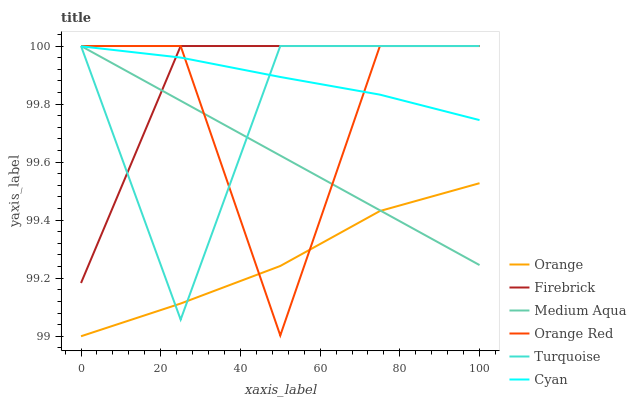Does Orange have the minimum area under the curve?
Answer yes or no. Yes. Does Firebrick have the maximum area under the curve?
Answer yes or no. Yes. Does Medium Aqua have the minimum area under the curve?
Answer yes or no. No. Does Medium Aqua have the maximum area under the curve?
Answer yes or no. No. Is Medium Aqua the smoothest?
Answer yes or no. Yes. Is Orange Red the roughest?
Answer yes or no. Yes. Is Firebrick the smoothest?
Answer yes or no. No. Is Firebrick the roughest?
Answer yes or no. No. Does Orange have the lowest value?
Answer yes or no. Yes. Does Firebrick have the lowest value?
Answer yes or no. No. Does Orange Red have the highest value?
Answer yes or no. Yes. Does Orange have the highest value?
Answer yes or no. No. Is Orange less than Cyan?
Answer yes or no. Yes. Is Firebrick greater than Orange?
Answer yes or no. Yes. Does Cyan intersect Firebrick?
Answer yes or no. Yes. Is Cyan less than Firebrick?
Answer yes or no. No. Is Cyan greater than Firebrick?
Answer yes or no. No. Does Orange intersect Cyan?
Answer yes or no. No. 